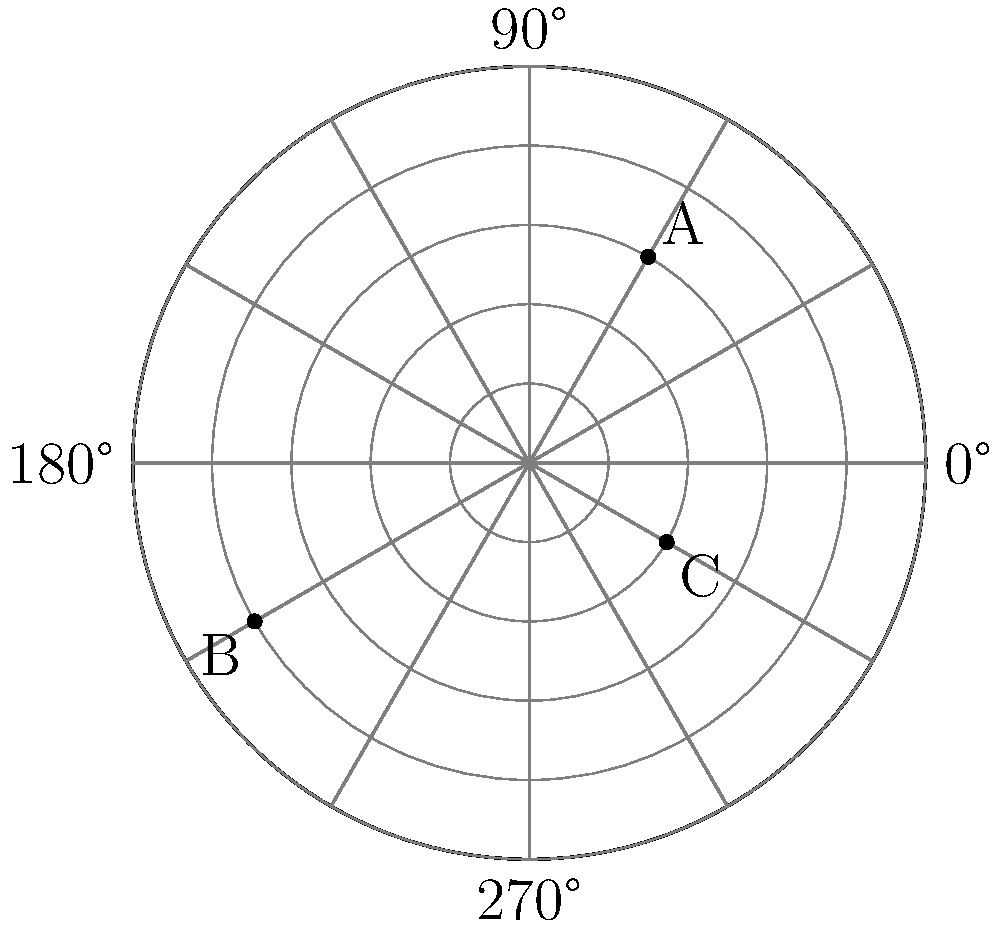In a 360-degree scene, three cameras (A, B, and C) are positioned using polar coordinates. Camera A is at $(3, 60°)$, B at $(4, 210°)$, and C at $(2, 330°)$. Which camera is closest to the center point, and what is its distance from the center? To determine which camera is closest to the center point, we need to compare their radial distances:

1. Camera A: $r_A = 3$
2. Camera B: $r_B = 4$
3. Camera C: $r_C = 2$

The radial distance represents how far each camera is from the center point. The smaller the radial distance, the closer the camera is to the center.

Comparing these values:

$r_C < r_A < r_B$

Therefore, Camera C is closest to the center point with a distance of 2 units.
Answer: Camera C, 2 units 